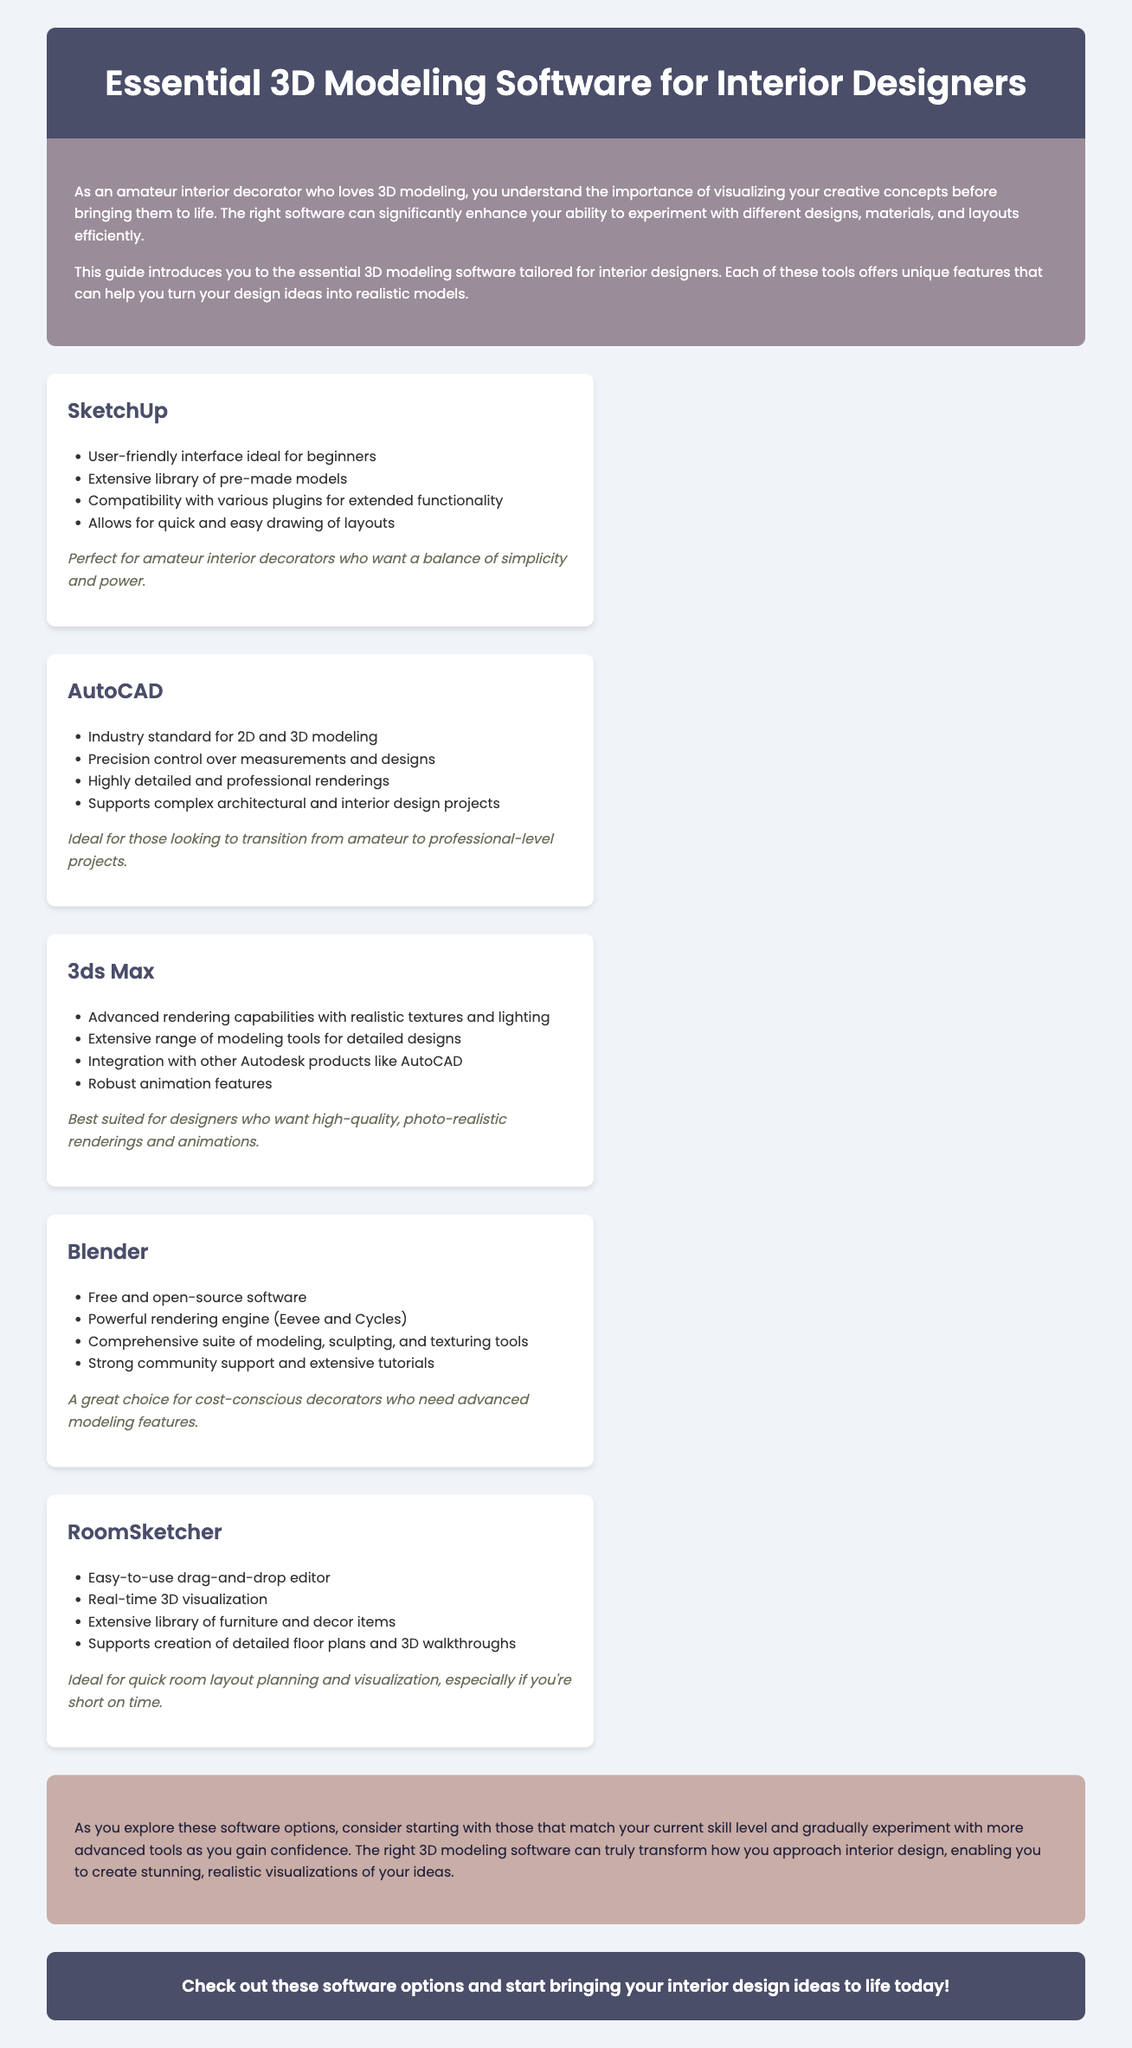What is the title of the document? The title of the document is specified in the `<title>` tag of the HTML, which is "Essential 3D Modeling Software for Interior Designers."
Answer: Essential 3D Modeling Software for Interior Designers Which software is noted for its user-friendly interface? The document lists "SketchUp" as having a user-friendly interface ideal for beginners.
Answer: SketchUp What is a key feature of AutoCAD? The document indicates that AutoCAD is known for precision control over measurements and designs.
Answer: Precision control Which software is free and open-source? The document states that "Blender" is free and open-source software.
Answer: Blender What type of design projects is AutoCAD ideal for? According to the document, AutoCAD is ideal for complex architectural and interior design projects.
Answer: Complex architectural and interior design projects Which software is best suited for high-quality renderings? The document specifies that "3ds Max" is best suited for designers wanting high-quality, photo-realistic renderings and animations.
Answer: 3ds Max What feature does RoomSketcher offer that enhances quick planning? The document mentions that RoomSketcher has an easy-to-use drag-and-drop editor which enhances quick planning.
Answer: Drag-and-drop editor What should decorators consider when choosing software according to the conclusion? The conclusion advises decorators to consider starting with software that matches their current skill level.
Answer: Current skill level What is the main purpose of the document? The main purpose of the document is to introduce essential 3D modeling software for interior designers.
Answer: Introduce essential 3D modeling software 